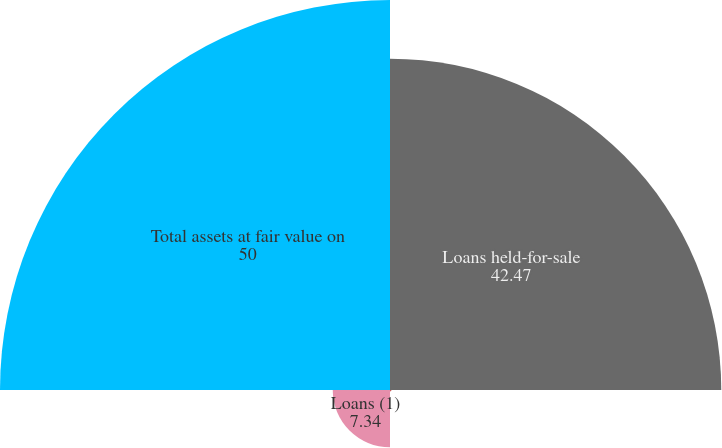Convert chart to OTSL. <chart><loc_0><loc_0><loc_500><loc_500><pie_chart><fcel>Loans held-for-sale<fcel>Other real estate owned<fcel>Loans (1)<fcel>Total assets at fair value on<nl><fcel>42.47%<fcel>0.19%<fcel>7.34%<fcel>50.0%<nl></chart> 